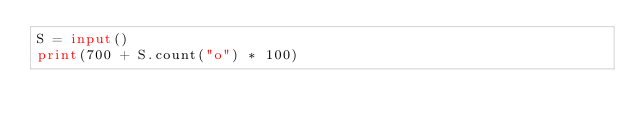<code> <loc_0><loc_0><loc_500><loc_500><_Python_>S = input()
print(700 + S.count("o") * 100)</code> 